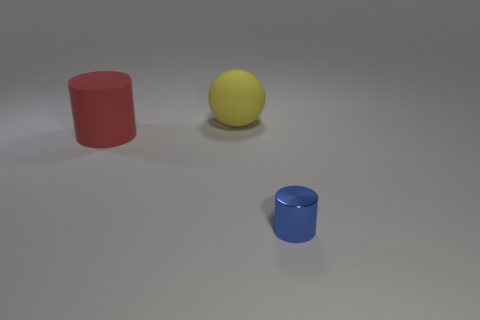There is a thing that is in front of the large matte object in front of the yellow thing; what is its shape? The object you're referring to appears to be a small blue cylinder positioned in the foreground, closer to the viewer's perspective than the large red cylindrical object and the yellow sphere behind it. 